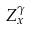Convert formula to latex. <formula><loc_0><loc_0><loc_500><loc_500>Z _ { x } ^ { \gamma }</formula> 